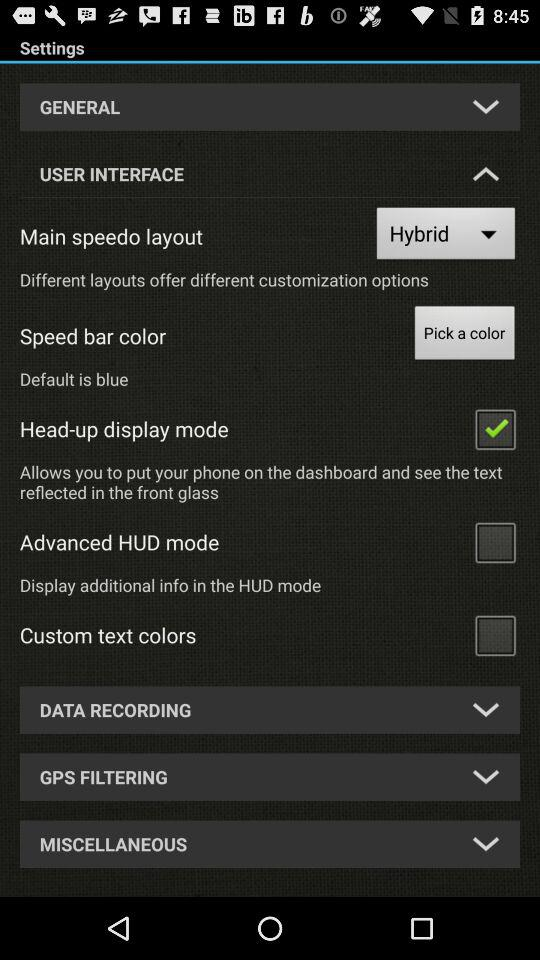What is the setting for the "Main speedo layout"? The setting is "Hybrid". 